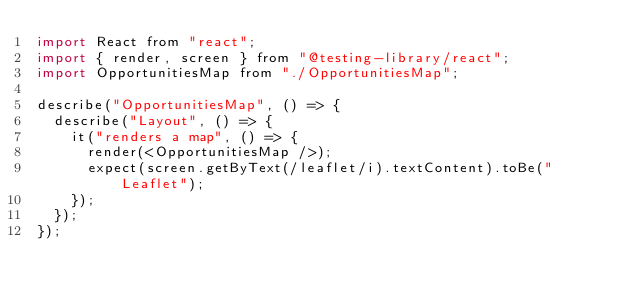Convert code to text. <code><loc_0><loc_0><loc_500><loc_500><_JavaScript_>import React from "react";
import { render, screen } from "@testing-library/react";
import OpportunitiesMap from "./OpportunitiesMap";

describe("OpportunitiesMap", () => {
  describe("Layout", () => {
    it("renders a map", () => {
      render(<OpportunitiesMap />);
      expect(screen.getByText(/leaflet/i).textContent).toBe("Leaflet");
    });
  });
});
</code> 